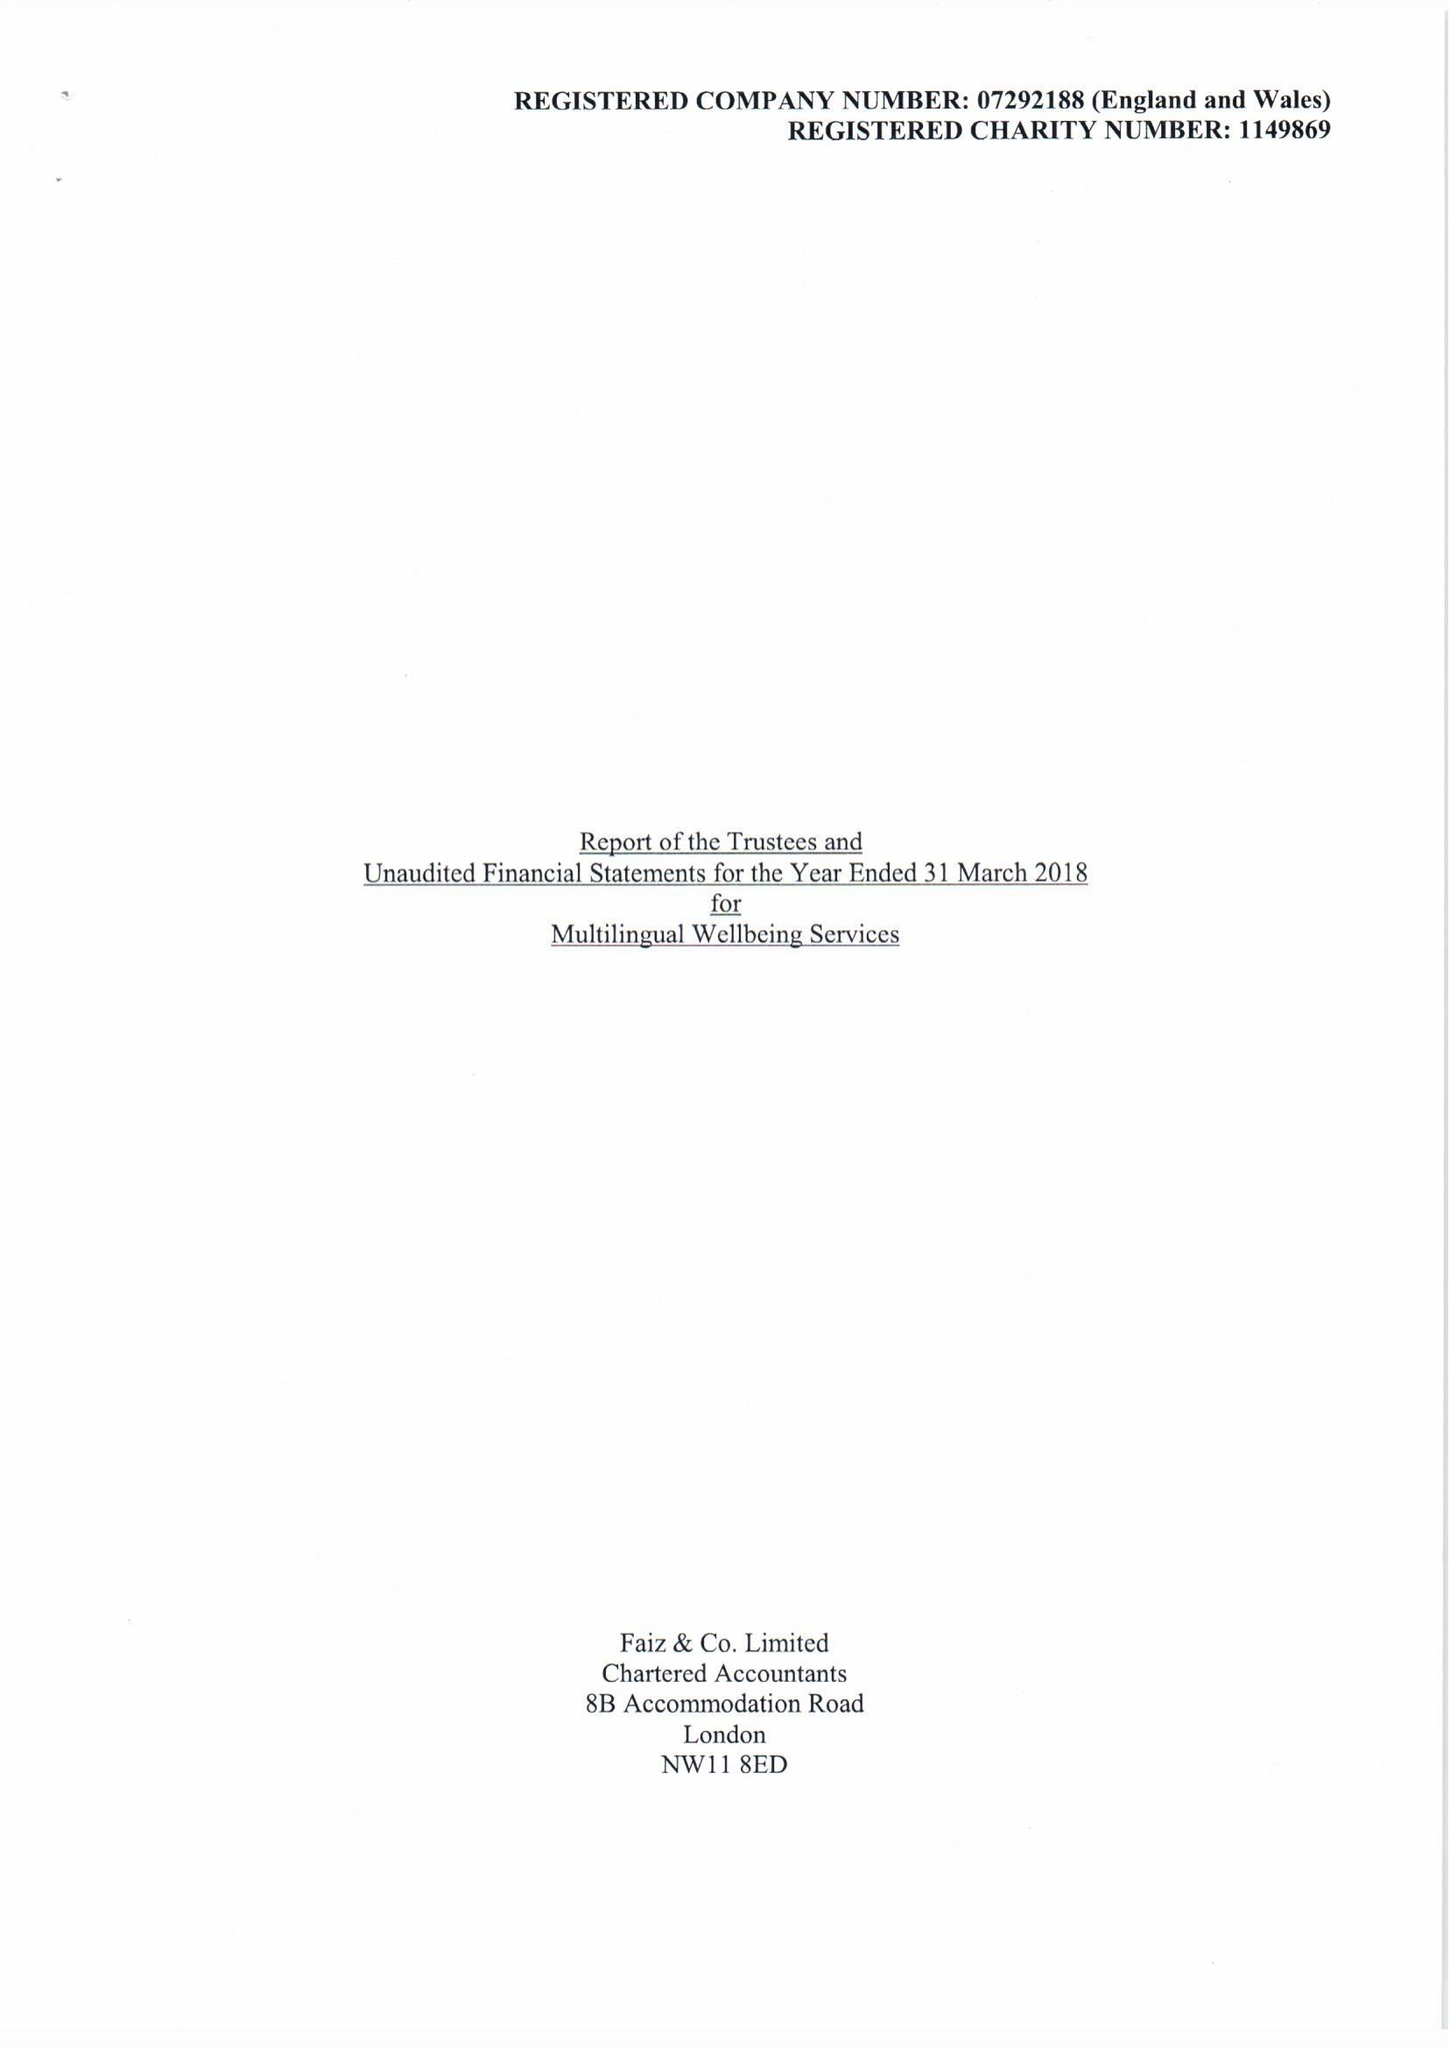What is the value for the address__post_town?
Answer the question using a single word or phrase. EDGWARE 